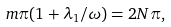<formula> <loc_0><loc_0><loc_500><loc_500>m \pi ( 1 + \lambda _ { 1 } / \omega ) = 2 N \pi ,</formula> 